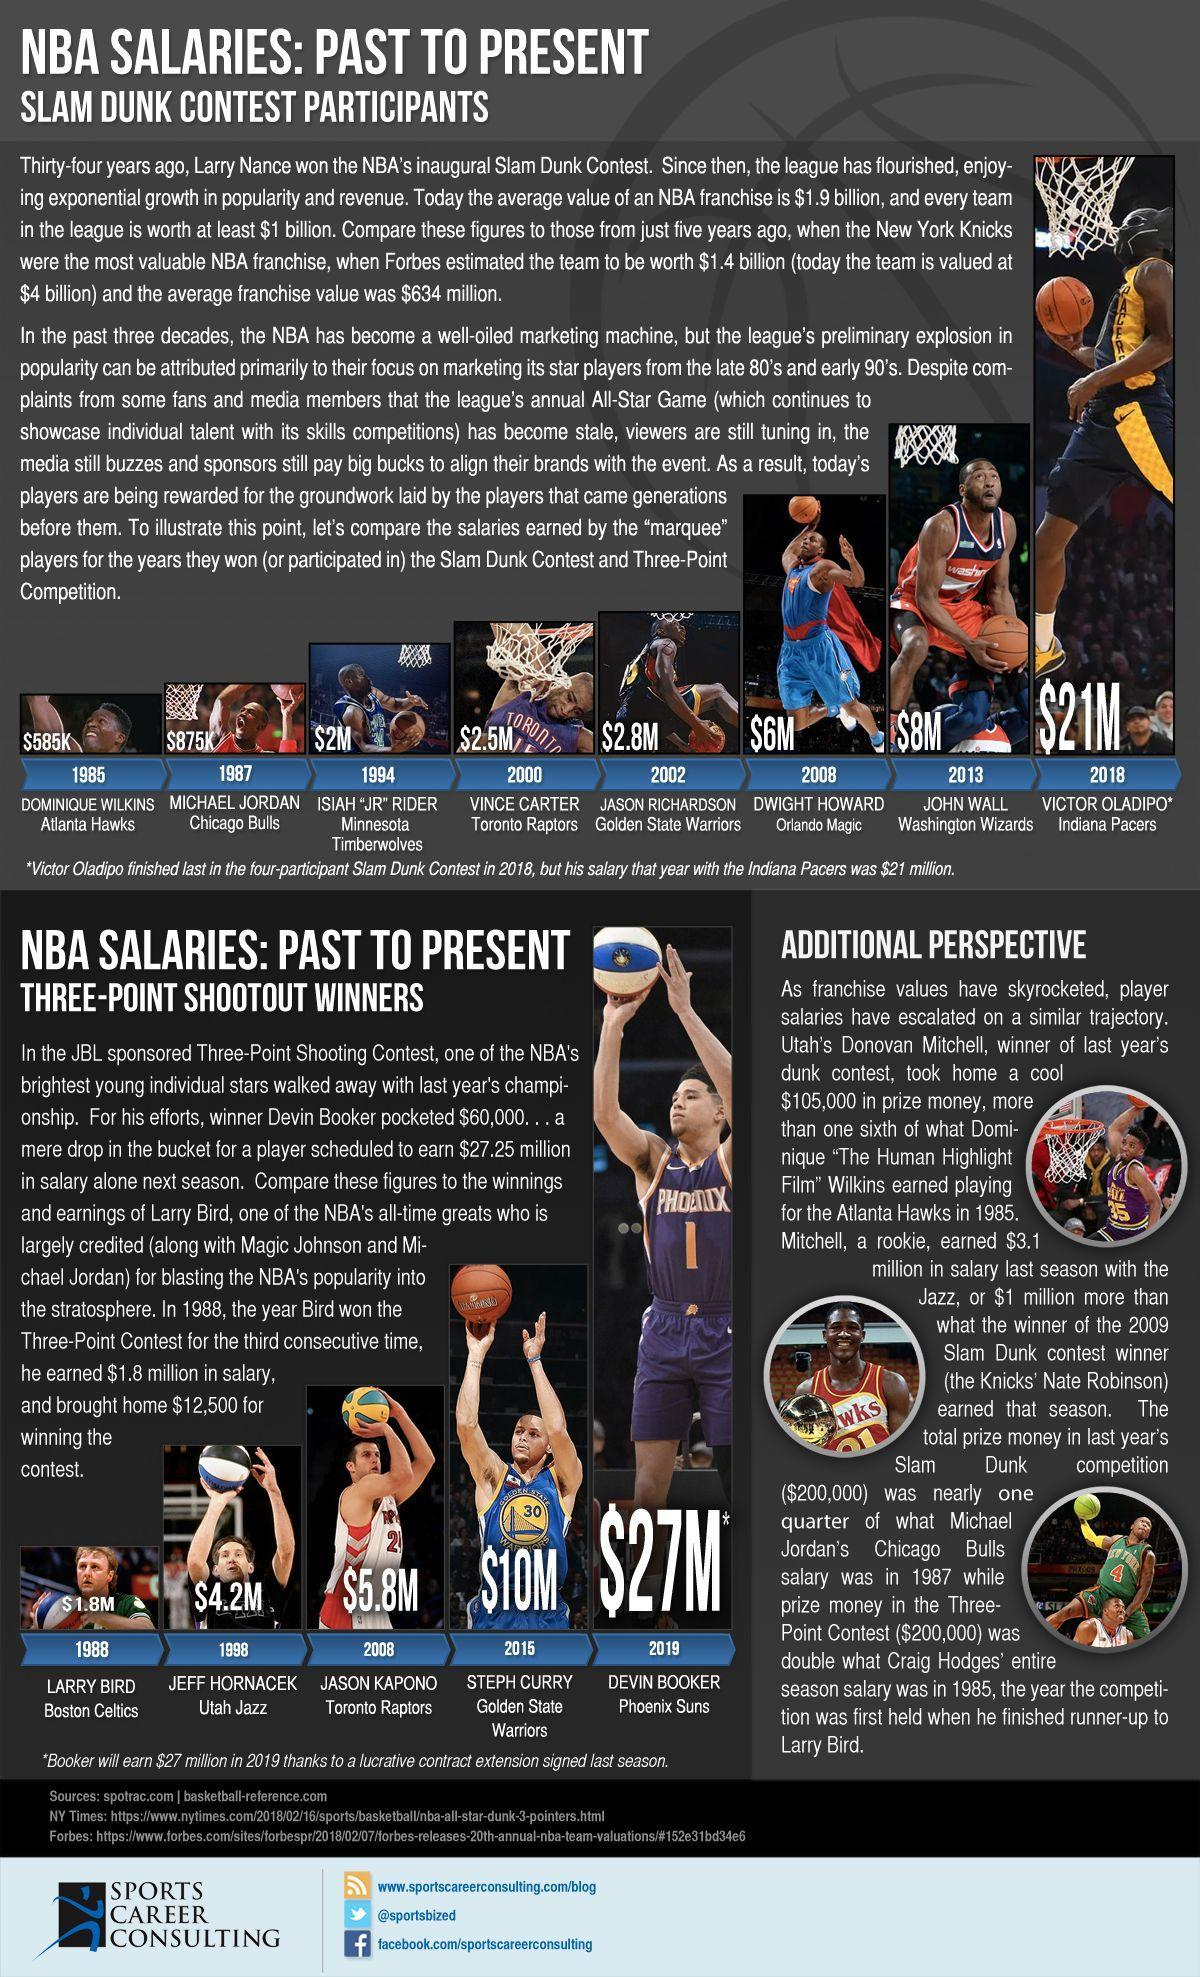Michael Jordan is in which team?
Answer the question with a short phrase. Chicago Bulls Who is the winner of the NBA's Slam Dunk Contest in 2008? Dwight Howard In which team the winner of the NBA's Slam Dunk Contest 2000 belongs? Toronto Raptors Jason Richardson is in which team? Golden State Warriors Who got the prize money of $2.5M in NBA's Slam Dunk contest? Vince Carter 